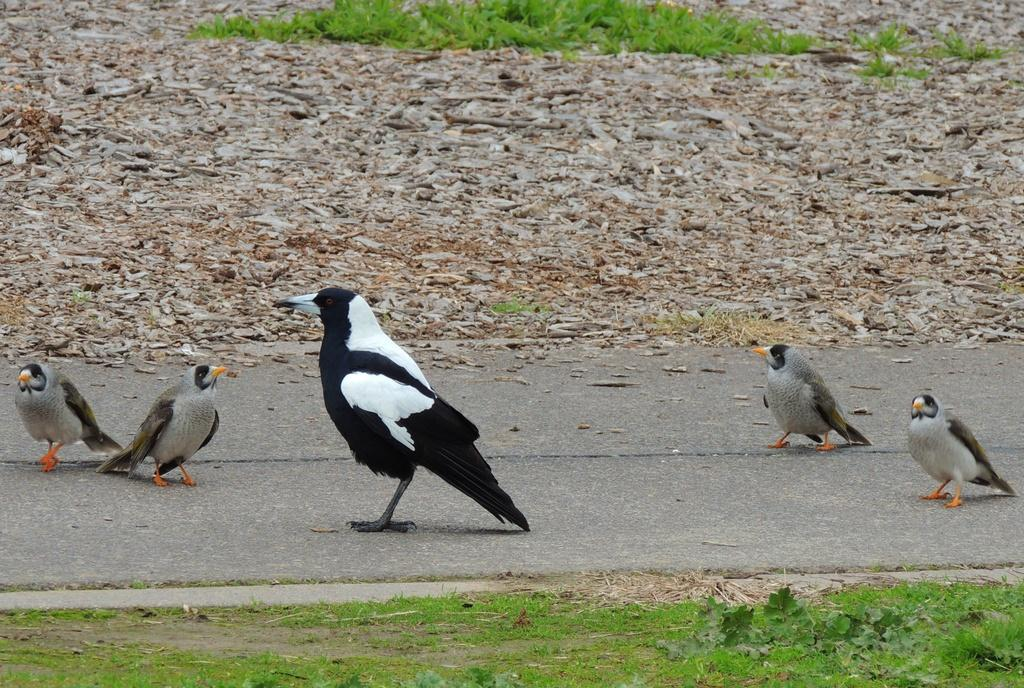What animals can be seen on the road in the image? There are birds on the road in the image. What type of vegetation is present at the bottom of the image? There is grass at the bottom of the image. What can be seen in the background of the image? There are stones visible in the background of the image. What type of magic is being performed by the pig in the image? There is no pig present in the image, so no magic can be observed. 